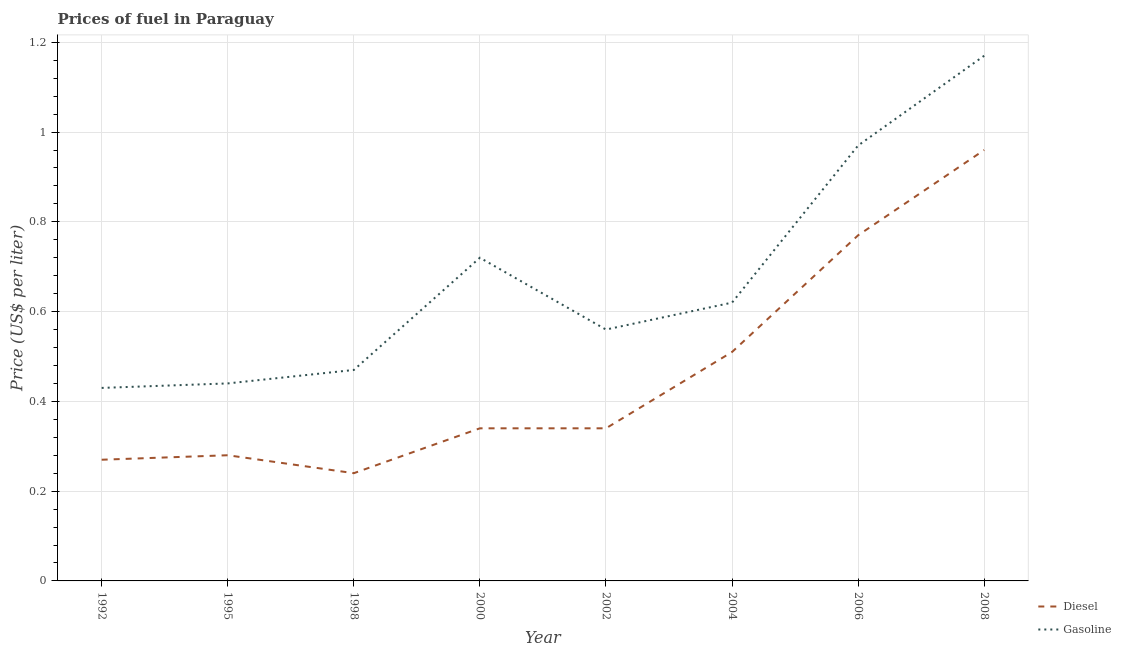Is the number of lines equal to the number of legend labels?
Provide a succinct answer. Yes. What is the diesel price in 2002?
Provide a succinct answer. 0.34. Across all years, what is the maximum gasoline price?
Provide a short and direct response. 1.17. Across all years, what is the minimum gasoline price?
Offer a terse response. 0.43. In which year was the gasoline price maximum?
Provide a short and direct response. 2008. In which year was the diesel price minimum?
Provide a short and direct response. 1998. What is the total diesel price in the graph?
Provide a succinct answer. 3.71. What is the difference between the gasoline price in 1992 and that in 2004?
Give a very brief answer. -0.19. What is the difference between the gasoline price in 2006 and the diesel price in 2008?
Your response must be concise. 0.01. What is the average gasoline price per year?
Offer a terse response. 0.67. In the year 2004, what is the difference between the gasoline price and diesel price?
Your response must be concise. 0.11. What is the ratio of the gasoline price in 2000 to that in 2008?
Your answer should be compact. 0.62. Is the gasoline price in 1992 less than that in 1998?
Your answer should be compact. Yes. What is the difference between the highest and the second highest gasoline price?
Ensure brevity in your answer.  0.2. What is the difference between the highest and the lowest gasoline price?
Your answer should be very brief. 0.74. In how many years, is the diesel price greater than the average diesel price taken over all years?
Offer a very short reply. 3. How many lines are there?
Offer a very short reply. 2. What is the difference between two consecutive major ticks on the Y-axis?
Give a very brief answer. 0.2. Are the values on the major ticks of Y-axis written in scientific E-notation?
Make the answer very short. No. What is the title of the graph?
Offer a terse response. Prices of fuel in Paraguay. Does "Boys" appear as one of the legend labels in the graph?
Give a very brief answer. No. What is the label or title of the X-axis?
Make the answer very short. Year. What is the label or title of the Y-axis?
Your answer should be compact. Price (US$ per liter). What is the Price (US$ per liter) of Diesel in 1992?
Your answer should be compact. 0.27. What is the Price (US$ per liter) of Gasoline in 1992?
Your answer should be compact. 0.43. What is the Price (US$ per liter) of Diesel in 1995?
Your answer should be very brief. 0.28. What is the Price (US$ per liter) of Gasoline in 1995?
Your answer should be very brief. 0.44. What is the Price (US$ per liter) of Diesel in 1998?
Keep it short and to the point. 0.24. What is the Price (US$ per liter) in Gasoline in 1998?
Make the answer very short. 0.47. What is the Price (US$ per liter) in Diesel in 2000?
Offer a very short reply. 0.34. What is the Price (US$ per liter) in Gasoline in 2000?
Your answer should be very brief. 0.72. What is the Price (US$ per liter) in Diesel in 2002?
Keep it short and to the point. 0.34. What is the Price (US$ per liter) in Gasoline in 2002?
Provide a succinct answer. 0.56. What is the Price (US$ per liter) of Diesel in 2004?
Keep it short and to the point. 0.51. What is the Price (US$ per liter) in Gasoline in 2004?
Your response must be concise. 0.62. What is the Price (US$ per liter) of Diesel in 2006?
Ensure brevity in your answer.  0.77. What is the Price (US$ per liter) of Diesel in 2008?
Provide a succinct answer. 0.96. What is the Price (US$ per liter) in Gasoline in 2008?
Your answer should be very brief. 1.17. Across all years, what is the maximum Price (US$ per liter) in Diesel?
Provide a succinct answer. 0.96. Across all years, what is the maximum Price (US$ per liter) of Gasoline?
Provide a succinct answer. 1.17. Across all years, what is the minimum Price (US$ per liter) in Diesel?
Your answer should be compact. 0.24. Across all years, what is the minimum Price (US$ per liter) in Gasoline?
Offer a very short reply. 0.43. What is the total Price (US$ per liter) in Diesel in the graph?
Offer a terse response. 3.71. What is the total Price (US$ per liter) of Gasoline in the graph?
Give a very brief answer. 5.38. What is the difference between the Price (US$ per liter) in Diesel in 1992 and that in 1995?
Offer a very short reply. -0.01. What is the difference between the Price (US$ per liter) of Gasoline in 1992 and that in 1995?
Offer a very short reply. -0.01. What is the difference between the Price (US$ per liter) of Gasoline in 1992 and that in 1998?
Your answer should be very brief. -0.04. What is the difference between the Price (US$ per liter) of Diesel in 1992 and that in 2000?
Ensure brevity in your answer.  -0.07. What is the difference between the Price (US$ per liter) of Gasoline in 1992 and that in 2000?
Your answer should be compact. -0.29. What is the difference between the Price (US$ per liter) in Diesel in 1992 and that in 2002?
Your answer should be compact. -0.07. What is the difference between the Price (US$ per liter) in Gasoline in 1992 and that in 2002?
Your answer should be very brief. -0.13. What is the difference between the Price (US$ per liter) in Diesel in 1992 and that in 2004?
Ensure brevity in your answer.  -0.24. What is the difference between the Price (US$ per liter) of Gasoline in 1992 and that in 2004?
Provide a succinct answer. -0.19. What is the difference between the Price (US$ per liter) in Diesel in 1992 and that in 2006?
Keep it short and to the point. -0.5. What is the difference between the Price (US$ per liter) of Gasoline in 1992 and that in 2006?
Keep it short and to the point. -0.54. What is the difference between the Price (US$ per liter) of Diesel in 1992 and that in 2008?
Keep it short and to the point. -0.69. What is the difference between the Price (US$ per liter) of Gasoline in 1992 and that in 2008?
Your answer should be very brief. -0.74. What is the difference between the Price (US$ per liter) of Diesel in 1995 and that in 1998?
Provide a succinct answer. 0.04. What is the difference between the Price (US$ per liter) of Gasoline in 1995 and that in 1998?
Keep it short and to the point. -0.03. What is the difference between the Price (US$ per liter) in Diesel in 1995 and that in 2000?
Your answer should be very brief. -0.06. What is the difference between the Price (US$ per liter) in Gasoline in 1995 and that in 2000?
Your answer should be very brief. -0.28. What is the difference between the Price (US$ per liter) of Diesel in 1995 and that in 2002?
Your answer should be very brief. -0.06. What is the difference between the Price (US$ per liter) of Gasoline in 1995 and that in 2002?
Offer a very short reply. -0.12. What is the difference between the Price (US$ per liter) in Diesel in 1995 and that in 2004?
Provide a succinct answer. -0.23. What is the difference between the Price (US$ per liter) of Gasoline in 1995 and that in 2004?
Offer a terse response. -0.18. What is the difference between the Price (US$ per liter) in Diesel in 1995 and that in 2006?
Make the answer very short. -0.49. What is the difference between the Price (US$ per liter) in Gasoline in 1995 and that in 2006?
Your answer should be very brief. -0.53. What is the difference between the Price (US$ per liter) in Diesel in 1995 and that in 2008?
Provide a succinct answer. -0.68. What is the difference between the Price (US$ per liter) in Gasoline in 1995 and that in 2008?
Give a very brief answer. -0.73. What is the difference between the Price (US$ per liter) in Diesel in 1998 and that in 2002?
Your response must be concise. -0.1. What is the difference between the Price (US$ per liter) in Gasoline in 1998 and that in 2002?
Ensure brevity in your answer.  -0.09. What is the difference between the Price (US$ per liter) in Diesel in 1998 and that in 2004?
Your answer should be very brief. -0.27. What is the difference between the Price (US$ per liter) in Gasoline in 1998 and that in 2004?
Provide a short and direct response. -0.15. What is the difference between the Price (US$ per liter) in Diesel in 1998 and that in 2006?
Your response must be concise. -0.53. What is the difference between the Price (US$ per liter) in Gasoline in 1998 and that in 2006?
Keep it short and to the point. -0.5. What is the difference between the Price (US$ per liter) in Diesel in 1998 and that in 2008?
Provide a succinct answer. -0.72. What is the difference between the Price (US$ per liter) of Gasoline in 2000 and that in 2002?
Keep it short and to the point. 0.16. What is the difference between the Price (US$ per liter) in Diesel in 2000 and that in 2004?
Make the answer very short. -0.17. What is the difference between the Price (US$ per liter) of Diesel in 2000 and that in 2006?
Ensure brevity in your answer.  -0.43. What is the difference between the Price (US$ per liter) in Gasoline in 2000 and that in 2006?
Offer a terse response. -0.25. What is the difference between the Price (US$ per liter) of Diesel in 2000 and that in 2008?
Ensure brevity in your answer.  -0.62. What is the difference between the Price (US$ per liter) of Gasoline in 2000 and that in 2008?
Ensure brevity in your answer.  -0.45. What is the difference between the Price (US$ per liter) of Diesel in 2002 and that in 2004?
Keep it short and to the point. -0.17. What is the difference between the Price (US$ per liter) in Gasoline in 2002 and that in 2004?
Ensure brevity in your answer.  -0.06. What is the difference between the Price (US$ per liter) in Diesel in 2002 and that in 2006?
Give a very brief answer. -0.43. What is the difference between the Price (US$ per liter) of Gasoline in 2002 and that in 2006?
Ensure brevity in your answer.  -0.41. What is the difference between the Price (US$ per liter) in Diesel in 2002 and that in 2008?
Your answer should be compact. -0.62. What is the difference between the Price (US$ per liter) in Gasoline in 2002 and that in 2008?
Ensure brevity in your answer.  -0.61. What is the difference between the Price (US$ per liter) of Diesel in 2004 and that in 2006?
Your response must be concise. -0.26. What is the difference between the Price (US$ per liter) in Gasoline in 2004 and that in 2006?
Offer a terse response. -0.35. What is the difference between the Price (US$ per liter) of Diesel in 2004 and that in 2008?
Offer a terse response. -0.45. What is the difference between the Price (US$ per liter) of Gasoline in 2004 and that in 2008?
Ensure brevity in your answer.  -0.55. What is the difference between the Price (US$ per liter) in Diesel in 2006 and that in 2008?
Ensure brevity in your answer.  -0.19. What is the difference between the Price (US$ per liter) of Diesel in 1992 and the Price (US$ per liter) of Gasoline in 1995?
Your answer should be very brief. -0.17. What is the difference between the Price (US$ per liter) of Diesel in 1992 and the Price (US$ per liter) of Gasoline in 1998?
Ensure brevity in your answer.  -0.2. What is the difference between the Price (US$ per liter) of Diesel in 1992 and the Price (US$ per liter) of Gasoline in 2000?
Ensure brevity in your answer.  -0.45. What is the difference between the Price (US$ per liter) of Diesel in 1992 and the Price (US$ per liter) of Gasoline in 2002?
Ensure brevity in your answer.  -0.29. What is the difference between the Price (US$ per liter) of Diesel in 1992 and the Price (US$ per liter) of Gasoline in 2004?
Your answer should be compact. -0.35. What is the difference between the Price (US$ per liter) of Diesel in 1992 and the Price (US$ per liter) of Gasoline in 2006?
Give a very brief answer. -0.7. What is the difference between the Price (US$ per liter) in Diesel in 1995 and the Price (US$ per liter) in Gasoline in 1998?
Provide a short and direct response. -0.19. What is the difference between the Price (US$ per liter) in Diesel in 1995 and the Price (US$ per liter) in Gasoline in 2000?
Your answer should be very brief. -0.44. What is the difference between the Price (US$ per liter) of Diesel in 1995 and the Price (US$ per liter) of Gasoline in 2002?
Offer a terse response. -0.28. What is the difference between the Price (US$ per liter) of Diesel in 1995 and the Price (US$ per liter) of Gasoline in 2004?
Your answer should be very brief. -0.34. What is the difference between the Price (US$ per liter) in Diesel in 1995 and the Price (US$ per liter) in Gasoline in 2006?
Your answer should be compact. -0.69. What is the difference between the Price (US$ per liter) of Diesel in 1995 and the Price (US$ per liter) of Gasoline in 2008?
Provide a succinct answer. -0.89. What is the difference between the Price (US$ per liter) of Diesel in 1998 and the Price (US$ per liter) of Gasoline in 2000?
Give a very brief answer. -0.48. What is the difference between the Price (US$ per liter) of Diesel in 1998 and the Price (US$ per liter) of Gasoline in 2002?
Keep it short and to the point. -0.32. What is the difference between the Price (US$ per liter) of Diesel in 1998 and the Price (US$ per liter) of Gasoline in 2004?
Give a very brief answer. -0.38. What is the difference between the Price (US$ per liter) in Diesel in 1998 and the Price (US$ per liter) in Gasoline in 2006?
Provide a succinct answer. -0.73. What is the difference between the Price (US$ per liter) in Diesel in 1998 and the Price (US$ per liter) in Gasoline in 2008?
Your answer should be compact. -0.93. What is the difference between the Price (US$ per liter) in Diesel in 2000 and the Price (US$ per liter) in Gasoline in 2002?
Provide a succinct answer. -0.22. What is the difference between the Price (US$ per liter) in Diesel in 2000 and the Price (US$ per liter) in Gasoline in 2004?
Your response must be concise. -0.28. What is the difference between the Price (US$ per liter) of Diesel in 2000 and the Price (US$ per liter) of Gasoline in 2006?
Ensure brevity in your answer.  -0.63. What is the difference between the Price (US$ per liter) of Diesel in 2000 and the Price (US$ per liter) of Gasoline in 2008?
Offer a terse response. -0.83. What is the difference between the Price (US$ per liter) of Diesel in 2002 and the Price (US$ per liter) of Gasoline in 2004?
Make the answer very short. -0.28. What is the difference between the Price (US$ per liter) of Diesel in 2002 and the Price (US$ per liter) of Gasoline in 2006?
Give a very brief answer. -0.63. What is the difference between the Price (US$ per liter) of Diesel in 2002 and the Price (US$ per liter) of Gasoline in 2008?
Provide a succinct answer. -0.83. What is the difference between the Price (US$ per liter) of Diesel in 2004 and the Price (US$ per liter) of Gasoline in 2006?
Your response must be concise. -0.46. What is the difference between the Price (US$ per liter) of Diesel in 2004 and the Price (US$ per liter) of Gasoline in 2008?
Keep it short and to the point. -0.66. What is the difference between the Price (US$ per liter) in Diesel in 2006 and the Price (US$ per liter) in Gasoline in 2008?
Your response must be concise. -0.4. What is the average Price (US$ per liter) in Diesel per year?
Make the answer very short. 0.46. What is the average Price (US$ per liter) in Gasoline per year?
Give a very brief answer. 0.67. In the year 1992, what is the difference between the Price (US$ per liter) in Diesel and Price (US$ per liter) in Gasoline?
Provide a short and direct response. -0.16. In the year 1995, what is the difference between the Price (US$ per liter) of Diesel and Price (US$ per liter) of Gasoline?
Your answer should be very brief. -0.16. In the year 1998, what is the difference between the Price (US$ per liter) in Diesel and Price (US$ per liter) in Gasoline?
Give a very brief answer. -0.23. In the year 2000, what is the difference between the Price (US$ per liter) in Diesel and Price (US$ per liter) in Gasoline?
Keep it short and to the point. -0.38. In the year 2002, what is the difference between the Price (US$ per liter) of Diesel and Price (US$ per liter) of Gasoline?
Offer a terse response. -0.22. In the year 2004, what is the difference between the Price (US$ per liter) of Diesel and Price (US$ per liter) of Gasoline?
Offer a very short reply. -0.11. In the year 2008, what is the difference between the Price (US$ per liter) in Diesel and Price (US$ per liter) in Gasoline?
Your response must be concise. -0.21. What is the ratio of the Price (US$ per liter) in Gasoline in 1992 to that in 1995?
Provide a short and direct response. 0.98. What is the ratio of the Price (US$ per liter) of Gasoline in 1992 to that in 1998?
Your answer should be very brief. 0.91. What is the ratio of the Price (US$ per liter) of Diesel in 1992 to that in 2000?
Your answer should be compact. 0.79. What is the ratio of the Price (US$ per liter) of Gasoline in 1992 to that in 2000?
Your response must be concise. 0.6. What is the ratio of the Price (US$ per liter) of Diesel in 1992 to that in 2002?
Provide a succinct answer. 0.79. What is the ratio of the Price (US$ per liter) in Gasoline in 1992 to that in 2002?
Make the answer very short. 0.77. What is the ratio of the Price (US$ per liter) in Diesel in 1992 to that in 2004?
Provide a succinct answer. 0.53. What is the ratio of the Price (US$ per liter) in Gasoline in 1992 to that in 2004?
Make the answer very short. 0.69. What is the ratio of the Price (US$ per liter) in Diesel in 1992 to that in 2006?
Keep it short and to the point. 0.35. What is the ratio of the Price (US$ per liter) in Gasoline in 1992 to that in 2006?
Make the answer very short. 0.44. What is the ratio of the Price (US$ per liter) of Diesel in 1992 to that in 2008?
Your response must be concise. 0.28. What is the ratio of the Price (US$ per liter) of Gasoline in 1992 to that in 2008?
Keep it short and to the point. 0.37. What is the ratio of the Price (US$ per liter) in Gasoline in 1995 to that in 1998?
Give a very brief answer. 0.94. What is the ratio of the Price (US$ per liter) in Diesel in 1995 to that in 2000?
Ensure brevity in your answer.  0.82. What is the ratio of the Price (US$ per liter) of Gasoline in 1995 to that in 2000?
Your answer should be very brief. 0.61. What is the ratio of the Price (US$ per liter) in Diesel in 1995 to that in 2002?
Offer a terse response. 0.82. What is the ratio of the Price (US$ per liter) in Gasoline in 1995 to that in 2002?
Your answer should be compact. 0.79. What is the ratio of the Price (US$ per liter) in Diesel in 1995 to that in 2004?
Your answer should be compact. 0.55. What is the ratio of the Price (US$ per liter) of Gasoline in 1995 to that in 2004?
Keep it short and to the point. 0.71. What is the ratio of the Price (US$ per liter) of Diesel in 1995 to that in 2006?
Provide a short and direct response. 0.36. What is the ratio of the Price (US$ per liter) of Gasoline in 1995 to that in 2006?
Your response must be concise. 0.45. What is the ratio of the Price (US$ per liter) in Diesel in 1995 to that in 2008?
Your response must be concise. 0.29. What is the ratio of the Price (US$ per liter) of Gasoline in 1995 to that in 2008?
Provide a short and direct response. 0.38. What is the ratio of the Price (US$ per liter) of Diesel in 1998 to that in 2000?
Offer a terse response. 0.71. What is the ratio of the Price (US$ per liter) of Gasoline in 1998 to that in 2000?
Ensure brevity in your answer.  0.65. What is the ratio of the Price (US$ per liter) of Diesel in 1998 to that in 2002?
Offer a very short reply. 0.71. What is the ratio of the Price (US$ per liter) of Gasoline in 1998 to that in 2002?
Provide a succinct answer. 0.84. What is the ratio of the Price (US$ per liter) in Diesel in 1998 to that in 2004?
Your answer should be very brief. 0.47. What is the ratio of the Price (US$ per liter) in Gasoline in 1998 to that in 2004?
Your answer should be compact. 0.76. What is the ratio of the Price (US$ per liter) of Diesel in 1998 to that in 2006?
Your response must be concise. 0.31. What is the ratio of the Price (US$ per liter) in Gasoline in 1998 to that in 2006?
Make the answer very short. 0.48. What is the ratio of the Price (US$ per liter) in Diesel in 1998 to that in 2008?
Provide a short and direct response. 0.25. What is the ratio of the Price (US$ per liter) in Gasoline in 1998 to that in 2008?
Your answer should be compact. 0.4. What is the ratio of the Price (US$ per liter) of Gasoline in 2000 to that in 2004?
Your answer should be compact. 1.16. What is the ratio of the Price (US$ per liter) of Diesel in 2000 to that in 2006?
Your answer should be compact. 0.44. What is the ratio of the Price (US$ per liter) in Gasoline in 2000 to that in 2006?
Your response must be concise. 0.74. What is the ratio of the Price (US$ per liter) in Diesel in 2000 to that in 2008?
Offer a terse response. 0.35. What is the ratio of the Price (US$ per liter) in Gasoline in 2000 to that in 2008?
Give a very brief answer. 0.62. What is the ratio of the Price (US$ per liter) of Gasoline in 2002 to that in 2004?
Your answer should be compact. 0.9. What is the ratio of the Price (US$ per liter) of Diesel in 2002 to that in 2006?
Your response must be concise. 0.44. What is the ratio of the Price (US$ per liter) of Gasoline in 2002 to that in 2006?
Provide a short and direct response. 0.58. What is the ratio of the Price (US$ per liter) of Diesel in 2002 to that in 2008?
Offer a terse response. 0.35. What is the ratio of the Price (US$ per liter) of Gasoline in 2002 to that in 2008?
Give a very brief answer. 0.48. What is the ratio of the Price (US$ per liter) of Diesel in 2004 to that in 2006?
Ensure brevity in your answer.  0.66. What is the ratio of the Price (US$ per liter) of Gasoline in 2004 to that in 2006?
Make the answer very short. 0.64. What is the ratio of the Price (US$ per liter) of Diesel in 2004 to that in 2008?
Provide a short and direct response. 0.53. What is the ratio of the Price (US$ per liter) of Gasoline in 2004 to that in 2008?
Provide a short and direct response. 0.53. What is the ratio of the Price (US$ per liter) in Diesel in 2006 to that in 2008?
Keep it short and to the point. 0.8. What is the ratio of the Price (US$ per liter) of Gasoline in 2006 to that in 2008?
Give a very brief answer. 0.83. What is the difference between the highest and the second highest Price (US$ per liter) of Diesel?
Your answer should be compact. 0.19. What is the difference between the highest and the lowest Price (US$ per liter) in Diesel?
Give a very brief answer. 0.72. What is the difference between the highest and the lowest Price (US$ per liter) of Gasoline?
Provide a succinct answer. 0.74. 